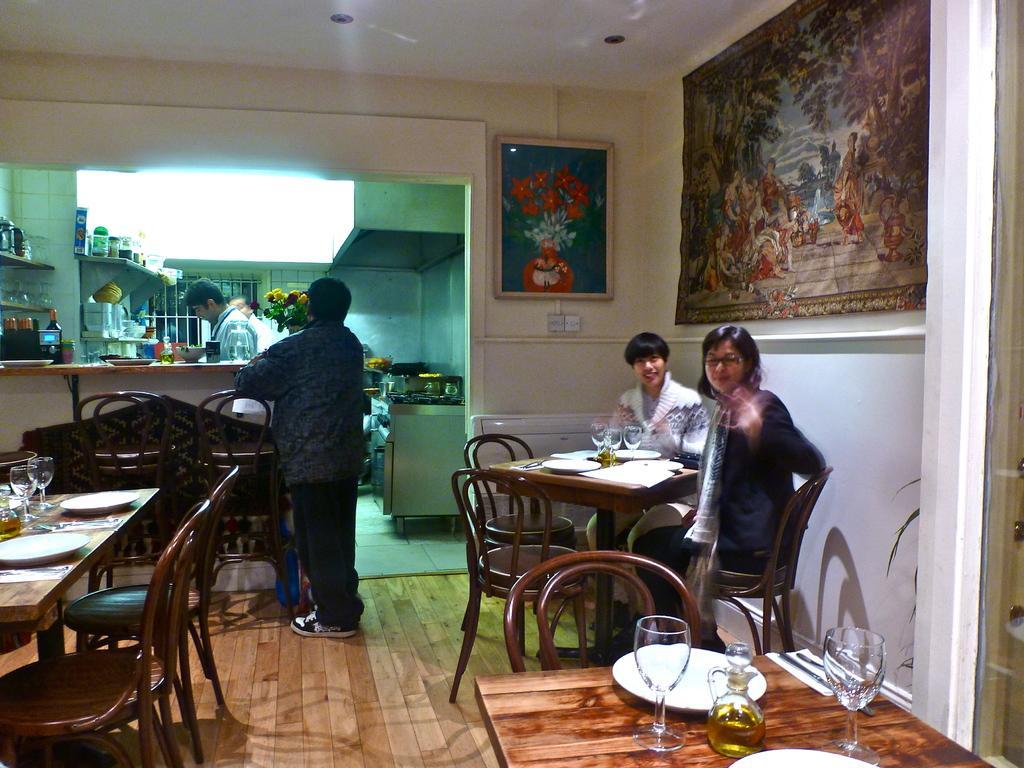How would you summarize this image in a sentence or two? In the image we can see there are people who are sitting on chair and a persons are standing. 